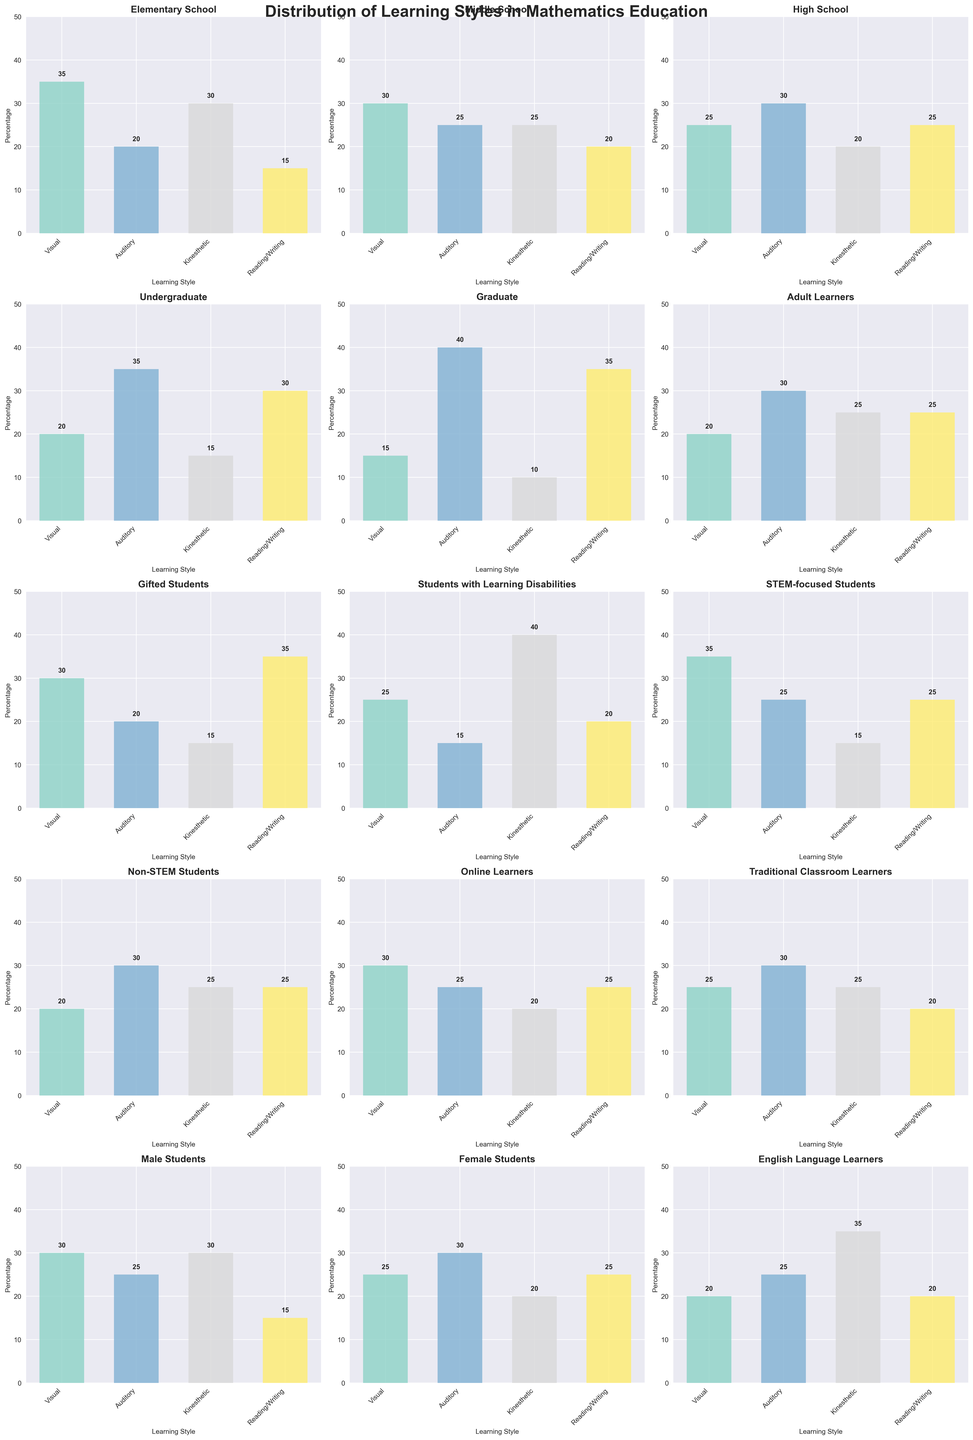Which learning style is most preferred by Graduate students? By looking at the subplot for Graduate students, the tallest bar represents the most preferred learning style, which is Reading/Writing.
Answer: Reading/Writing Which group has the highest percentage of Auditory learners, and what is the value? Observing the subplots, Graduate students have the tallest Auditory bar at 40%.
Answer: Graduate students, 40% How do the percentages of Kinesthetic learners compare between Elementary School and Students with Learning Disabilities? The subplot for Elementary School shows Kinesthetic learners at 30%, while for Students with Learning Disabilities, it is 40%. The percentage is higher for Students with Learning Disabilities.
Answer: Students with Learning Disabilities have 10% more What is the average percentage of Visual learners across all groups? Sum the percentages of Visual learners from all subplots and divide by the number of groups: (35+30+25+20+15+20+30+25+35+20+30+25+30+25+20)/15 = 25.33%.
Answer: 25.33% What is the combined percentage of students preferring Reading/Writing in High School and Undergraduate groups? For High School, Reading/Writing is at 25%, and for Undergraduate it is 30%. Adding these gives 25% + 30% = 55%.
Answer: 55% Which group has more Visual learners, STEM-focused Students or Non-STEM Students? The subplot for STEM-focused Students shows Visual learners at 35%, while Non-STEM Students have 20%. Therefore, STEM-focused Students have more Visual learners.
Answer: STEM-focused Students Compare the total percentages of Kinesthetic and Auditory learners among Middle School students. Middle School students have 25% Auditory and 25% Kinesthetic learners. Since both bars are of equal height, the percentages are the same.
Answer: Kinesthetic and Auditory are equal What is the difference in percentage points for Visual learners between Elementary School and High School students? The subplot for Elementary School shows Visual learners at 35%, and for High School, it is 25%. The difference is 35% - 25% = 10%.
Answer: 10% Identify the subgroup with the least preference for Kinesthetic learning style and state the percentage. Graduate students have the smallest bar for Kinesthetic learners at 10%.
Answer: Graduate students, 10% Find the total percentage of each group's most preferred learning style. Which group's total is the highest and how much is it? Identify the tallest bar in each subplot, and sum the percentages. The highest total is 40% for Graduate students' Auditory learners.
Answer: Graduate students, 40% 